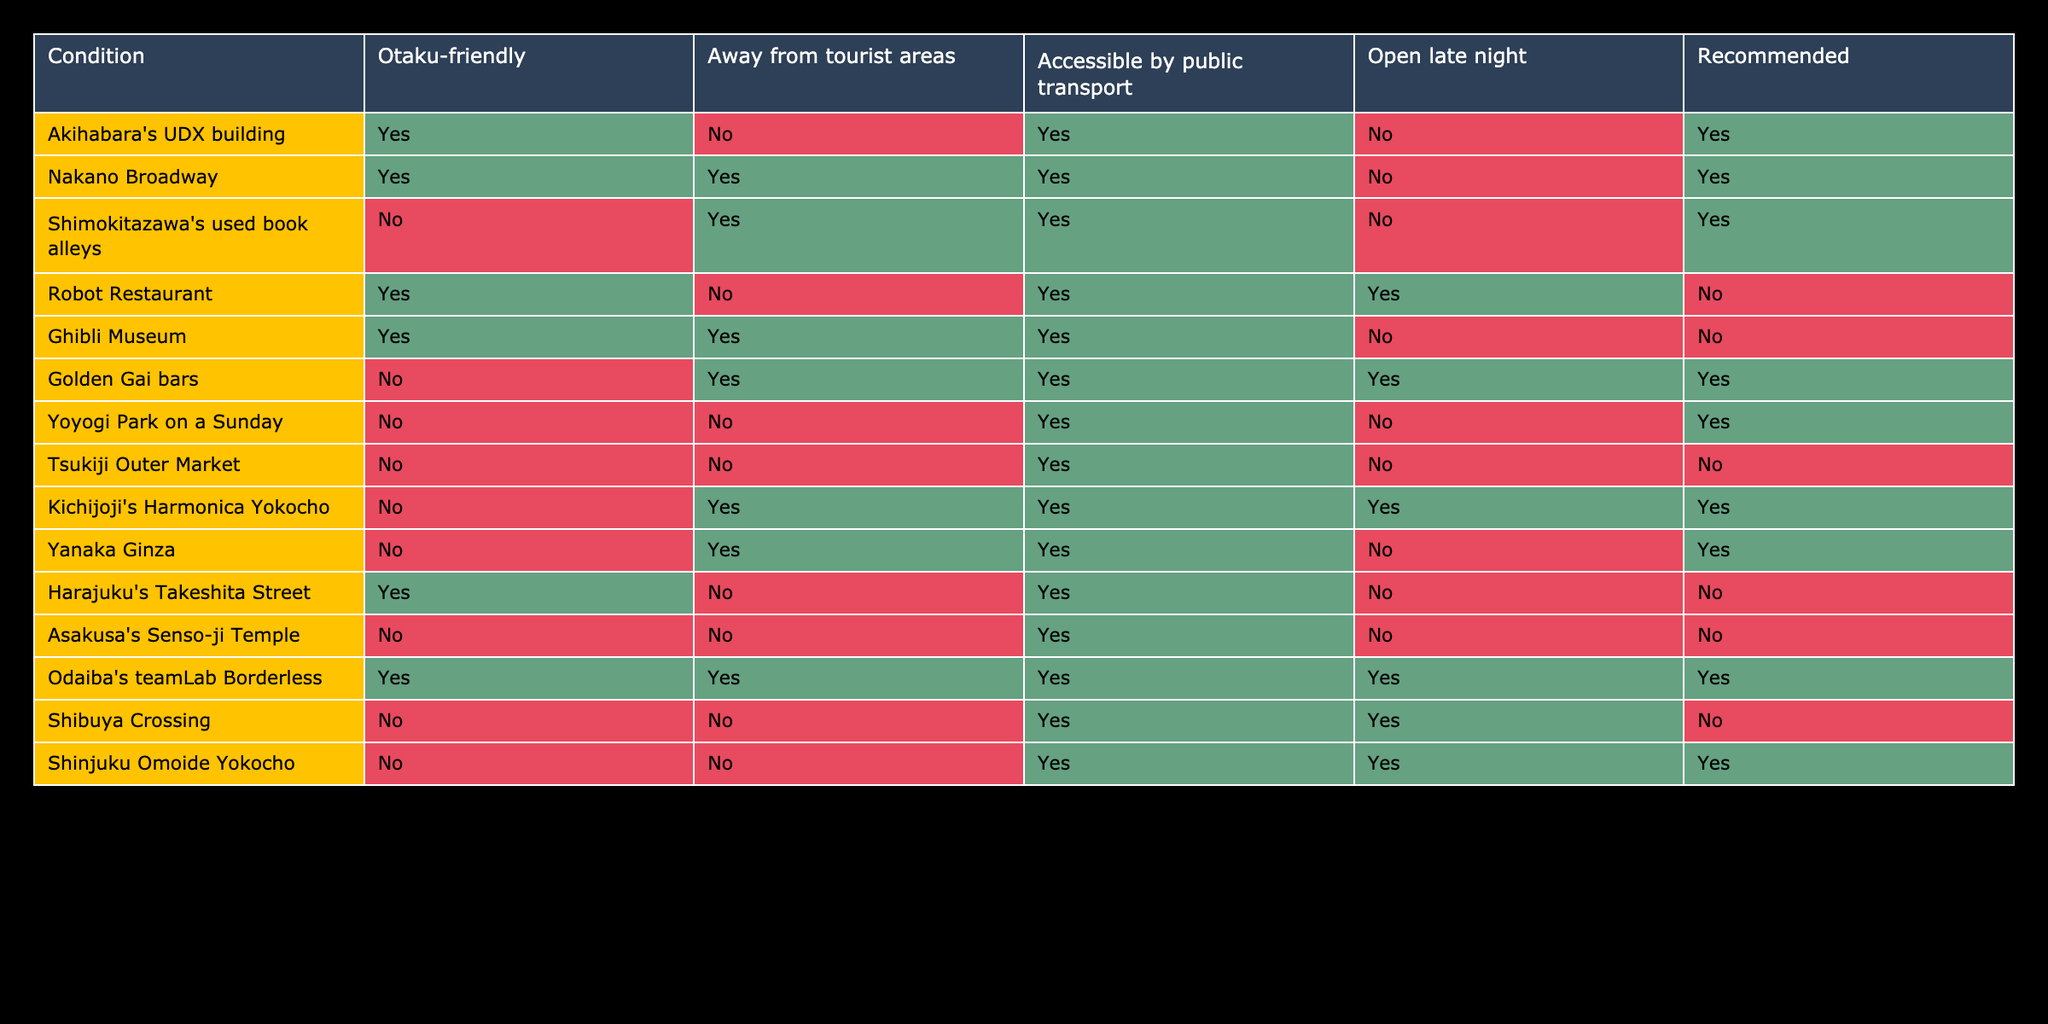What hidden gem in Tokyo is both otaku-friendly and accessible by public transport? Looking at the table, we need to find a location where both the "Otaku-friendly" and "Accessible by public transport" columns are marked as true. The entries that meet this condition are "Akihabara's UDX building" and "Nakano Broadway." However, "Akihabara's UDX building" is not recommended, and "Nakano Broadway" is, so the answer is "Nakano Broadway."
Answer: Nakano Broadway Is Yoyogi Park open late night? The table directly indicates that Yoyogi Park on a Sunday has "Open late night" marked as false. Thus, it is not open late night.
Answer: No How many places are both otaku-friendly and open late night? To find this, we count the rows where both "Otaku-friendly" is true and "Open late night" is true. By examining the table, only "Robot Restaurant" fits the criteria but is not recommended, so there are zero recommended places.
Answer: 0 Which locations are recommended and away from tourist areas? We need to look at rows where both the "Recommended" column is true and the "Away from tourist areas" column is true. The entries that meet this condition are "Nakano Broadway," "Shimokitazawa's used book alleys," "Golden Gai bars," "Kichijoji's Harmonica Yokocho," and "Yanaka Ginza." Therefore, there are five recommended places that fit this criteria.
Answer: 5 Is Tsukiji Outer Market away from tourist areas? From the table, we can see that "Tsukiji Outer Market" has the "Away from tourist areas" marked as false. Therefore, it is not away from tourist areas.
Answer: No What is the total number of recommended places that are both otaku-friendly and accessible by public transport? We look for entries with both criteria of "Otaku-friendly" and "Accessible by public transport" being true, and mark whether they are recommended. The only entries that meet both criteria are "Akihabara's UDX building" and "Nakano Broadway." Of these, only "Nakano Broadway" is recommended, so the total count is 1.
Answer: 1 Are there any places recommended that are accessible by public transport but not otaku-friendly? To answer, we need to find recommended places with "Accessible by public transport" as true and "Otaku-friendly" as false. The entries that fit are "Golden Gai bars," "Yoyogi Park on a Sunday," "Yanaka Ginza," and "Shinjuku Omoide Yokocho," resulting in four places that meet these criteria.
Answer: 4 Which recommended place is the only one that is both open late night and away from tourist areas? To answer, we search for all recommended places that are marked true for both "Open late night" and "Away from tourist areas." The places "Golden Gai bars" and "Shinjuku Omoide Yokocho" meet these criteria, with only "Golden Gai bars" being recommended. Hence, it is the only one fitting these conditions.
Answer: Golden Gai bars 